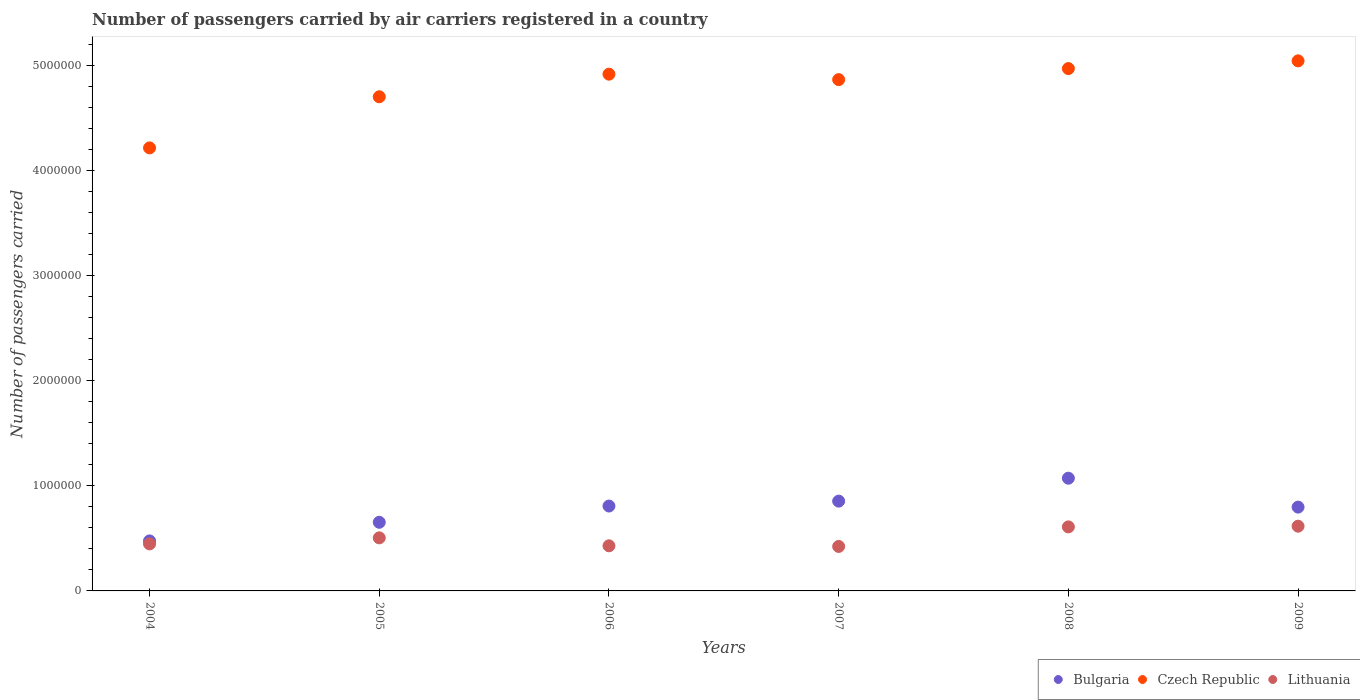Is the number of dotlines equal to the number of legend labels?
Keep it short and to the point. Yes. What is the number of passengers carried by air carriers in Czech Republic in 2005?
Give a very brief answer. 4.71e+06. Across all years, what is the maximum number of passengers carried by air carriers in Bulgaria?
Offer a terse response. 1.07e+06. Across all years, what is the minimum number of passengers carried by air carriers in Czech Republic?
Offer a terse response. 4.22e+06. In which year was the number of passengers carried by air carriers in Czech Republic maximum?
Offer a terse response. 2009. What is the total number of passengers carried by air carriers in Czech Republic in the graph?
Your answer should be compact. 2.87e+07. What is the difference between the number of passengers carried by air carriers in Czech Republic in 2007 and that in 2009?
Your answer should be very brief. -1.79e+05. What is the difference between the number of passengers carried by air carriers in Czech Republic in 2009 and the number of passengers carried by air carriers in Bulgaria in 2008?
Ensure brevity in your answer.  3.97e+06. What is the average number of passengers carried by air carriers in Bulgaria per year?
Offer a very short reply. 7.78e+05. In the year 2009, what is the difference between the number of passengers carried by air carriers in Lithuania and number of passengers carried by air carriers in Bulgaria?
Offer a very short reply. -1.82e+05. What is the ratio of the number of passengers carried by air carriers in Czech Republic in 2007 to that in 2009?
Give a very brief answer. 0.96. Is the difference between the number of passengers carried by air carriers in Lithuania in 2006 and 2008 greater than the difference between the number of passengers carried by air carriers in Bulgaria in 2006 and 2008?
Your response must be concise. Yes. What is the difference between the highest and the second highest number of passengers carried by air carriers in Lithuania?
Ensure brevity in your answer.  6667. What is the difference between the highest and the lowest number of passengers carried by air carriers in Czech Republic?
Keep it short and to the point. 8.29e+05. Is the sum of the number of passengers carried by air carriers in Lithuania in 2007 and 2008 greater than the maximum number of passengers carried by air carriers in Bulgaria across all years?
Provide a succinct answer. No. Does the number of passengers carried by air carriers in Czech Republic monotonically increase over the years?
Provide a succinct answer. No. How many years are there in the graph?
Your answer should be very brief. 6. Are the values on the major ticks of Y-axis written in scientific E-notation?
Ensure brevity in your answer.  No. Does the graph contain any zero values?
Offer a very short reply. No. Where does the legend appear in the graph?
Your answer should be very brief. Bottom right. How many legend labels are there?
Give a very brief answer. 3. How are the legend labels stacked?
Ensure brevity in your answer.  Horizontal. What is the title of the graph?
Provide a short and direct response. Number of passengers carried by air carriers registered in a country. Does "Azerbaijan" appear as one of the legend labels in the graph?
Provide a short and direct response. No. What is the label or title of the Y-axis?
Ensure brevity in your answer.  Number of passengers carried. What is the Number of passengers carried in Bulgaria in 2004?
Give a very brief answer. 4.76e+05. What is the Number of passengers carried in Czech Republic in 2004?
Offer a very short reply. 4.22e+06. What is the Number of passengers carried in Lithuania in 2004?
Your response must be concise. 4.48e+05. What is the Number of passengers carried in Bulgaria in 2005?
Offer a terse response. 6.54e+05. What is the Number of passengers carried of Czech Republic in 2005?
Offer a terse response. 4.71e+06. What is the Number of passengers carried in Lithuania in 2005?
Your answer should be compact. 5.05e+05. What is the Number of passengers carried in Bulgaria in 2006?
Offer a terse response. 8.08e+05. What is the Number of passengers carried of Czech Republic in 2006?
Your answer should be compact. 4.92e+06. What is the Number of passengers carried of Lithuania in 2006?
Make the answer very short. 4.30e+05. What is the Number of passengers carried of Bulgaria in 2007?
Keep it short and to the point. 8.55e+05. What is the Number of passengers carried in Czech Republic in 2007?
Offer a very short reply. 4.87e+06. What is the Number of passengers carried in Lithuania in 2007?
Your response must be concise. 4.24e+05. What is the Number of passengers carried in Bulgaria in 2008?
Offer a terse response. 1.07e+06. What is the Number of passengers carried of Czech Republic in 2008?
Your answer should be very brief. 4.97e+06. What is the Number of passengers carried in Lithuania in 2008?
Offer a terse response. 6.10e+05. What is the Number of passengers carried of Bulgaria in 2009?
Your answer should be very brief. 7.98e+05. What is the Number of passengers carried of Czech Republic in 2009?
Provide a short and direct response. 5.05e+06. What is the Number of passengers carried in Lithuania in 2009?
Keep it short and to the point. 6.17e+05. Across all years, what is the maximum Number of passengers carried in Bulgaria?
Your answer should be very brief. 1.07e+06. Across all years, what is the maximum Number of passengers carried of Czech Republic?
Your response must be concise. 5.05e+06. Across all years, what is the maximum Number of passengers carried in Lithuania?
Provide a succinct answer. 6.17e+05. Across all years, what is the minimum Number of passengers carried of Bulgaria?
Your answer should be compact. 4.76e+05. Across all years, what is the minimum Number of passengers carried of Czech Republic?
Make the answer very short. 4.22e+06. Across all years, what is the minimum Number of passengers carried of Lithuania?
Give a very brief answer. 4.24e+05. What is the total Number of passengers carried of Bulgaria in the graph?
Make the answer very short. 4.67e+06. What is the total Number of passengers carried in Czech Republic in the graph?
Keep it short and to the point. 2.87e+07. What is the total Number of passengers carried in Lithuania in the graph?
Provide a succinct answer. 3.03e+06. What is the difference between the Number of passengers carried in Bulgaria in 2004 and that in 2005?
Offer a terse response. -1.77e+05. What is the difference between the Number of passengers carried in Czech Republic in 2004 and that in 2005?
Make the answer very short. -4.87e+05. What is the difference between the Number of passengers carried of Lithuania in 2004 and that in 2005?
Your answer should be very brief. -5.75e+04. What is the difference between the Number of passengers carried of Bulgaria in 2004 and that in 2006?
Make the answer very short. -3.32e+05. What is the difference between the Number of passengers carried of Czech Republic in 2004 and that in 2006?
Provide a short and direct response. -7.02e+05. What is the difference between the Number of passengers carried of Lithuania in 2004 and that in 2006?
Offer a very short reply. 1.82e+04. What is the difference between the Number of passengers carried of Bulgaria in 2004 and that in 2007?
Offer a very short reply. -3.79e+05. What is the difference between the Number of passengers carried of Czech Republic in 2004 and that in 2007?
Provide a short and direct response. -6.50e+05. What is the difference between the Number of passengers carried of Lithuania in 2004 and that in 2007?
Provide a succinct answer. 2.43e+04. What is the difference between the Number of passengers carried of Bulgaria in 2004 and that in 2008?
Your response must be concise. -5.97e+05. What is the difference between the Number of passengers carried in Czech Republic in 2004 and that in 2008?
Your answer should be very brief. -7.55e+05. What is the difference between the Number of passengers carried in Lithuania in 2004 and that in 2008?
Your answer should be compact. -1.62e+05. What is the difference between the Number of passengers carried in Bulgaria in 2004 and that in 2009?
Ensure brevity in your answer.  -3.22e+05. What is the difference between the Number of passengers carried in Czech Republic in 2004 and that in 2009?
Your answer should be very brief. -8.29e+05. What is the difference between the Number of passengers carried of Lithuania in 2004 and that in 2009?
Give a very brief answer. -1.69e+05. What is the difference between the Number of passengers carried in Bulgaria in 2005 and that in 2006?
Your answer should be compact. -1.55e+05. What is the difference between the Number of passengers carried of Czech Republic in 2005 and that in 2006?
Your answer should be very brief. -2.15e+05. What is the difference between the Number of passengers carried of Lithuania in 2005 and that in 2006?
Your answer should be very brief. 7.58e+04. What is the difference between the Number of passengers carried in Bulgaria in 2005 and that in 2007?
Provide a succinct answer. -2.02e+05. What is the difference between the Number of passengers carried of Czech Republic in 2005 and that in 2007?
Provide a succinct answer. -1.63e+05. What is the difference between the Number of passengers carried of Lithuania in 2005 and that in 2007?
Keep it short and to the point. 8.18e+04. What is the difference between the Number of passengers carried in Bulgaria in 2005 and that in 2008?
Offer a very short reply. -4.20e+05. What is the difference between the Number of passengers carried of Czech Republic in 2005 and that in 2008?
Keep it short and to the point. -2.69e+05. What is the difference between the Number of passengers carried of Lithuania in 2005 and that in 2008?
Your answer should be compact. -1.04e+05. What is the difference between the Number of passengers carried in Bulgaria in 2005 and that in 2009?
Give a very brief answer. -1.44e+05. What is the difference between the Number of passengers carried in Czech Republic in 2005 and that in 2009?
Offer a very short reply. -3.42e+05. What is the difference between the Number of passengers carried of Lithuania in 2005 and that in 2009?
Provide a succinct answer. -1.11e+05. What is the difference between the Number of passengers carried of Bulgaria in 2006 and that in 2007?
Provide a short and direct response. -4.68e+04. What is the difference between the Number of passengers carried in Czech Republic in 2006 and that in 2007?
Offer a terse response. 5.20e+04. What is the difference between the Number of passengers carried in Lithuania in 2006 and that in 2007?
Your answer should be very brief. 6072. What is the difference between the Number of passengers carried in Bulgaria in 2006 and that in 2008?
Your response must be concise. -2.65e+05. What is the difference between the Number of passengers carried of Czech Republic in 2006 and that in 2008?
Ensure brevity in your answer.  -5.33e+04. What is the difference between the Number of passengers carried of Lithuania in 2006 and that in 2008?
Keep it short and to the point. -1.80e+05. What is the difference between the Number of passengers carried of Bulgaria in 2006 and that in 2009?
Make the answer very short. 1.03e+04. What is the difference between the Number of passengers carried in Czech Republic in 2006 and that in 2009?
Keep it short and to the point. -1.27e+05. What is the difference between the Number of passengers carried of Lithuania in 2006 and that in 2009?
Ensure brevity in your answer.  -1.87e+05. What is the difference between the Number of passengers carried in Bulgaria in 2007 and that in 2008?
Make the answer very short. -2.18e+05. What is the difference between the Number of passengers carried in Czech Republic in 2007 and that in 2008?
Provide a short and direct response. -1.05e+05. What is the difference between the Number of passengers carried of Lithuania in 2007 and that in 2008?
Keep it short and to the point. -1.86e+05. What is the difference between the Number of passengers carried in Bulgaria in 2007 and that in 2009?
Provide a succinct answer. 5.71e+04. What is the difference between the Number of passengers carried of Czech Republic in 2007 and that in 2009?
Your response must be concise. -1.79e+05. What is the difference between the Number of passengers carried in Lithuania in 2007 and that in 2009?
Your answer should be very brief. -1.93e+05. What is the difference between the Number of passengers carried of Bulgaria in 2008 and that in 2009?
Ensure brevity in your answer.  2.75e+05. What is the difference between the Number of passengers carried of Czech Republic in 2008 and that in 2009?
Provide a short and direct response. -7.35e+04. What is the difference between the Number of passengers carried of Lithuania in 2008 and that in 2009?
Provide a short and direct response. -6667. What is the difference between the Number of passengers carried of Bulgaria in 2004 and the Number of passengers carried of Czech Republic in 2005?
Provide a succinct answer. -4.23e+06. What is the difference between the Number of passengers carried of Bulgaria in 2004 and the Number of passengers carried of Lithuania in 2005?
Your response must be concise. -2.91e+04. What is the difference between the Number of passengers carried in Czech Republic in 2004 and the Number of passengers carried in Lithuania in 2005?
Ensure brevity in your answer.  3.71e+06. What is the difference between the Number of passengers carried of Bulgaria in 2004 and the Number of passengers carried of Czech Republic in 2006?
Ensure brevity in your answer.  -4.45e+06. What is the difference between the Number of passengers carried of Bulgaria in 2004 and the Number of passengers carried of Lithuania in 2006?
Your response must be concise. 4.66e+04. What is the difference between the Number of passengers carried of Czech Republic in 2004 and the Number of passengers carried of Lithuania in 2006?
Ensure brevity in your answer.  3.79e+06. What is the difference between the Number of passengers carried of Bulgaria in 2004 and the Number of passengers carried of Czech Republic in 2007?
Offer a very short reply. -4.39e+06. What is the difference between the Number of passengers carried in Bulgaria in 2004 and the Number of passengers carried in Lithuania in 2007?
Your answer should be very brief. 5.27e+04. What is the difference between the Number of passengers carried of Czech Republic in 2004 and the Number of passengers carried of Lithuania in 2007?
Ensure brevity in your answer.  3.80e+06. What is the difference between the Number of passengers carried of Bulgaria in 2004 and the Number of passengers carried of Czech Republic in 2008?
Your response must be concise. -4.50e+06. What is the difference between the Number of passengers carried in Bulgaria in 2004 and the Number of passengers carried in Lithuania in 2008?
Offer a very short reply. -1.34e+05. What is the difference between the Number of passengers carried in Czech Republic in 2004 and the Number of passengers carried in Lithuania in 2008?
Provide a short and direct response. 3.61e+06. What is the difference between the Number of passengers carried of Bulgaria in 2004 and the Number of passengers carried of Czech Republic in 2009?
Your response must be concise. -4.57e+06. What is the difference between the Number of passengers carried in Bulgaria in 2004 and the Number of passengers carried in Lithuania in 2009?
Ensure brevity in your answer.  -1.40e+05. What is the difference between the Number of passengers carried of Czech Republic in 2004 and the Number of passengers carried of Lithuania in 2009?
Keep it short and to the point. 3.60e+06. What is the difference between the Number of passengers carried of Bulgaria in 2005 and the Number of passengers carried of Czech Republic in 2006?
Provide a short and direct response. -4.27e+06. What is the difference between the Number of passengers carried in Bulgaria in 2005 and the Number of passengers carried in Lithuania in 2006?
Give a very brief answer. 2.24e+05. What is the difference between the Number of passengers carried of Czech Republic in 2005 and the Number of passengers carried of Lithuania in 2006?
Provide a succinct answer. 4.28e+06. What is the difference between the Number of passengers carried of Bulgaria in 2005 and the Number of passengers carried of Czech Republic in 2007?
Provide a succinct answer. -4.22e+06. What is the difference between the Number of passengers carried of Bulgaria in 2005 and the Number of passengers carried of Lithuania in 2007?
Make the answer very short. 2.30e+05. What is the difference between the Number of passengers carried of Czech Republic in 2005 and the Number of passengers carried of Lithuania in 2007?
Ensure brevity in your answer.  4.28e+06. What is the difference between the Number of passengers carried in Bulgaria in 2005 and the Number of passengers carried in Czech Republic in 2008?
Your answer should be compact. -4.32e+06. What is the difference between the Number of passengers carried of Bulgaria in 2005 and the Number of passengers carried of Lithuania in 2008?
Offer a terse response. 4.39e+04. What is the difference between the Number of passengers carried in Czech Republic in 2005 and the Number of passengers carried in Lithuania in 2008?
Your answer should be compact. 4.10e+06. What is the difference between the Number of passengers carried in Bulgaria in 2005 and the Number of passengers carried in Czech Republic in 2009?
Your answer should be compact. -4.39e+06. What is the difference between the Number of passengers carried in Bulgaria in 2005 and the Number of passengers carried in Lithuania in 2009?
Provide a short and direct response. 3.72e+04. What is the difference between the Number of passengers carried of Czech Republic in 2005 and the Number of passengers carried of Lithuania in 2009?
Provide a succinct answer. 4.09e+06. What is the difference between the Number of passengers carried in Bulgaria in 2006 and the Number of passengers carried in Czech Republic in 2007?
Provide a succinct answer. -4.06e+06. What is the difference between the Number of passengers carried of Bulgaria in 2006 and the Number of passengers carried of Lithuania in 2007?
Your response must be concise. 3.85e+05. What is the difference between the Number of passengers carried in Czech Republic in 2006 and the Number of passengers carried in Lithuania in 2007?
Provide a short and direct response. 4.50e+06. What is the difference between the Number of passengers carried in Bulgaria in 2006 and the Number of passengers carried in Czech Republic in 2008?
Make the answer very short. -4.17e+06. What is the difference between the Number of passengers carried of Bulgaria in 2006 and the Number of passengers carried of Lithuania in 2008?
Ensure brevity in your answer.  1.99e+05. What is the difference between the Number of passengers carried in Czech Republic in 2006 and the Number of passengers carried in Lithuania in 2008?
Your answer should be compact. 4.31e+06. What is the difference between the Number of passengers carried in Bulgaria in 2006 and the Number of passengers carried in Czech Republic in 2009?
Your answer should be compact. -4.24e+06. What is the difference between the Number of passengers carried in Bulgaria in 2006 and the Number of passengers carried in Lithuania in 2009?
Ensure brevity in your answer.  1.92e+05. What is the difference between the Number of passengers carried in Czech Republic in 2006 and the Number of passengers carried in Lithuania in 2009?
Offer a terse response. 4.31e+06. What is the difference between the Number of passengers carried in Bulgaria in 2007 and the Number of passengers carried in Czech Republic in 2008?
Keep it short and to the point. -4.12e+06. What is the difference between the Number of passengers carried in Bulgaria in 2007 and the Number of passengers carried in Lithuania in 2008?
Make the answer very short. 2.45e+05. What is the difference between the Number of passengers carried in Czech Republic in 2007 and the Number of passengers carried in Lithuania in 2008?
Offer a very short reply. 4.26e+06. What is the difference between the Number of passengers carried of Bulgaria in 2007 and the Number of passengers carried of Czech Republic in 2009?
Your response must be concise. -4.19e+06. What is the difference between the Number of passengers carried of Bulgaria in 2007 and the Number of passengers carried of Lithuania in 2009?
Make the answer very short. 2.39e+05. What is the difference between the Number of passengers carried in Czech Republic in 2007 and the Number of passengers carried in Lithuania in 2009?
Keep it short and to the point. 4.25e+06. What is the difference between the Number of passengers carried of Bulgaria in 2008 and the Number of passengers carried of Czech Republic in 2009?
Offer a very short reply. -3.97e+06. What is the difference between the Number of passengers carried in Bulgaria in 2008 and the Number of passengers carried in Lithuania in 2009?
Offer a very short reply. 4.57e+05. What is the difference between the Number of passengers carried of Czech Republic in 2008 and the Number of passengers carried of Lithuania in 2009?
Provide a short and direct response. 4.36e+06. What is the average Number of passengers carried in Bulgaria per year?
Your answer should be compact. 7.78e+05. What is the average Number of passengers carried in Czech Republic per year?
Give a very brief answer. 4.79e+06. What is the average Number of passengers carried of Lithuania per year?
Provide a short and direct response. 5.05e+05. In the year 2004, what is the difference between the Number of passengers carried of Bulgaria and Number of passengers carried of Czech Republic?
Ensure brevity in your answer.  -3.74e+06. In the year 2004, what is the difference between the Number of passengers carried of Bulgaria and Number of passengers carried of Lithuania?
Offer a terse response. 2.84e+04. In the year 2004, what is the difference between the Number of passengers carried of Czech Republic and Number of passengers carried of Lithuania?
Ensure brevity in your answer.  3.77e+06. In the year 2005, what is the difference between the Number of passengers carried of Bulgaria and Number of passengers carried of Czech Republic?
Ensure brevity in your answer.  -4.05e+06. In the year 2005, what is the difference between the Number of passengers carried of Bulgaria and Number of passengers carried of Lithuania?
Ensure brevity in your answer.  1.48e+05. In the year 2005, what is the difference between the Number of passengers carried of Czech Republic and Number of passengers carried of Lithuania?
Your answer should be compact. 4.20e+06. In the year 2006, what is the difference between the Number of passengers carried of Bulgaria and Number of passengers carried of Czech Republic?
Provide a short and direct response. -4.11e+06. In the year 2006, what is the difference between the Number of passengers carried in Bulgaria and Number of passengers carried in Lithuania?
Your answer should be compact. 3.79e+05. In the year 2006, what is the difference between the Number of passengers carried of Czech Republic and Number of passengers carried of Lithuania?
Provide a succinct answer. 4.49e+06. In the year 2007, what is the difference between the Number of passengers carried of Bulgaria and Number of passengers carried of Czech Republic?
Ensure brevity in your answer.  -4.01e+06. In the year 2007, what is the difference between the Number of passengers carried of Bulgaria and Number of passengers carried of Lithuania?
Offer a very short reply. 4.32e+05. In the year 2007, what is the difference between the Number of passengers carried of Czech Republic and Number of passengers carried of Lithuania?
Offer a terse response. 4.45e+06. In the year 2008, what is the difference between the Number of passengers carried in Bulgaria and Number of passengers carried in Czech Republic?
Make the answer very short. -3.90e+06. In the year 2008, what is the difference between the Number of passengers carried of Bulgaria and Number of passengers carried of Lithuania?
Ensure brevity in your answer.  4.64e+05. In the year 2008, what is the difference between the Number of passengers carried of Czech Republic and Number of passengers carried of Lithuania?
Offer a very short reply. 4.37e+06. In the year 2009, what is the difference between the Number of passengers carried of Bulgaria and Number of passengers carried of Czech Republic?
Give a very brief answer. -4.25e+06. In the year 2009, what is the difference between the Number of passengers carried in Bulgaria and Number of passengers carried in Lithuania?
Provide a short and direct response. 1.82e+05. In the year 2009, what is the difference between the Number of passengers carried in Czech Republic and Number of passengers carried in Lithuania?
Provide a succinct answer. 4.43e+06. What is the ratio of the Number of passengers carried of Bulgaria in 2004 to that in 2005?
Provide a short and direct response. 0.73. What is the ratio of the Number of passengers carried of Czech Republic in 2004 to that in 2005?
Ensure brevity in your answer.  0.9. What is the ratio of the Number of passengers carried in Lithuania in 2004 to that in 2005?
Your answer should be very brief. 0.89. What is the ratio of the Number of passengers carried in Bulgaria in 2004 to that in 2006?
Give a very brief answer. 0.59. What is the ratio of the Number of passengers carried of Czech Republic in 2004 to that in 2006?
Keep it short and to the point. 0.86. What is the ratio of the Number of passengers carried in Lithuania in 2004 to that in 2006?
Ensure brevity in your answer.  1.04. What is the ratio of the Number of passengers carried in Bulgaria in 2004 to that in 2007?
Your response must be concise. 0.56. What is the ratio of the Number of passengers carried in Czech Republic in 2004 to that in 2007?
Keep it short and to the point. 0.87. What is the ratio of the Number of passengers carried in Lithuania in 2004 to that in 2007?
Your answer should be compact. 1.06. What is the ratio of the Number of passengers carried of Bulgaria in 2004 to that in 2008?
Make the answer very short. 0.44. What is the ratio of the Number of passengers carried in Czech Republic in 2004 to that in 2008?
Keep it short and to the point. 0.85. What is the ratio of the Number of passengers carried in Lithuania in 2004 to that in 2008?
Offer a terse response. 0.73. What is the ratio of the Number of passengers carried of Bulgaria in 2004 to that in 2009?
Ensure brevity in your answer.  0.6. What is the ratio of the Number of passengers carried in Czech Republic in 2004 to that in 2009?
Provide a succinct answer. 0.84. What is the ratio of the Number of passengers carried in Lithuania in 2004 to that in 2009?
Keep it short and to the point. 0.73. What is the ratio of the Number of passengers carried in Bulgaria in 2005 to that in 2006?
Offer a very short reply. 0.81. What is the ratio of the Number of passengers carried in Czech Republic in 2005 to that in 2006?
Provide a succinct answer. 0.96. What is the ratio of the Number of passengers carried in Lithuania in 2005 to that in 2006?
Your answer should be very brief. 1.18. What is the ratio of the Number of passengers carried in Bulgaria in 2005 to that in 2007?
Provide a short and direct response. 0.76. What is the ratio of the Number of passengers carried in Czech Republic in 2005 to that in 2007?
Keep it short and to the point. 0.97. What is the ratio of the Number of passengers carried of Lithuania in 2005 to that in 2007?
Offer a terse response. 1.19. What is the ratio of the Number of passengers carried of Bulgaria in 2005 to that in 2008?
Offer a terse response. 0.61. What is the ratio of the Number of passengers carried in Czech Republic in 2005 to that in 2008?
Make the answer very short. 0.95. What is the ratio of the Number of passengers carried in Lithuania in 2005 to that in 2008?
Make the answer very short. 0.83. What is the ratio of the Number of passengers carried of Bulgaria in 2005 to that in 2009?
Provide a short and direct response. 0.82. What is the ratio of the Number of passengers carried in Czech Republic in 2005 to that in 2009?
Offer a very short reply. 0.93. What is the ratio of the Number of passengers carried of Lithuania in 2005 to that in 2009?
Give a very brief answer. 0.82. What is the ratio of the Number of passengers carried of Bulgaria in 2006 to that in 2007?
Offer a terse response. 0.95. What is the ratio of the Number of passengers carried of Czech Republic in 2006 to that in 2007?
Give a very brief answer. 1.01. What is the ratio of the Number of passengers carried of Lithuania in 2006 to that in 2007?
Give a very brief answer. 1.01. What is the ratio of the Number of passengers carried of Bulgaria in 2006 to that in 2008?
Give a very brief answer. 0.75. What is the ratio of the Number of passengers carried of Czech Republic in 2006 to that in 2008?
Offer a very short reply. 0.99. What is the ratio of the Number of passengers carried in Lithuania in 2006 to that in 2008?
Your answer should be compact. 0.7. What is the ratio of the Number of passengers carried of Bulgaria in 2006 to that in 2009?
Offer a very short reply. 1.01. What is the ratio of the Number of passengers carried in Czech Republic in 2006 to that in 2009?
Keep it short and to the point. 0.97. What is the ratio of the Number of passengers carried of Lithuania in 2006 to that in 2009?
Make the answer very short. 0.7. What is the ratio of the Number of passengers carried in Bulgaria in 2007 to that in 2008?
Your answer should be compact. 0.8. What is the ratio of the Number of passengers carried in Czech Republic in 2007 to that in 2008?
Your response must be concise. 0.98. What is the ratio of the Number of passengers carried of Lithuania in 2007 to that in 2008?
Give a very brief answer. 0.69. What is the ratio of the Number of passengers carried in Bulgaria in 2007 to that in 2009?
Ensure brevity in your answer.  1.07. What is the ratio of the Number of passengers carried in Czech Republic in 2007 to that in 2009?
Provide a short and direct response. 0.96. What is the ratio of the Number of passengers carried of Lithuania in 2007 to that in 2009?
Your answer should be very brief. 0.69. What is the ratio of the Number of passengers carried of Bulgaria in 2008 to that in 2009?
Offer a very short reply. 1.34. What is the ratio of the Number of passengers carried of Czech Republic in 2008 to that in 2009?
Provide a succinct answer. 0.99. What is the difference between the highest and the second highest Number of passengers carried of Bulgaria?
Ensure brevity in your answer.  2.18e+05. What is the difference between the highest and the second highest Number of passengers carried in Czech Republic?
Offer a very short reply. 7.35e+04. What is the difference between the highest and the second highest Number of passengers carried in Lithuania?
Provide a succinct answer. 6667. What is the difference between the highest and the lowest Number of passengers carried in Bulgaria?
Offer a very short reply. 5.97e+05. What is the difference between the highest and the lowest Number of passengers carried in Czech Republic?
Offer a terse response. 8.29e+05. What is the difference between the highest and the lowest Number of passengers carried in Lithuania?
Make the answer very short. 1.93e+05. 